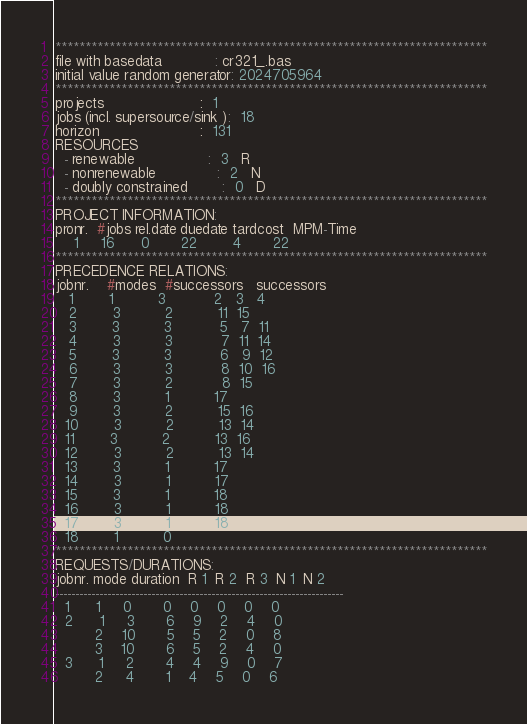<code> <loc_0><loc_0><loc_500><loc_500><_ObjectiveC_>************************************************************************
file with basedata            : cr321_.bas
initial value random generator: 2024705964
************************************************************************
projects                      :  1
jobs (incl. supersource/sink ):  18
horizon                       :  131
RESOURCES
  - renewable                 :  3   R
  - nonrenewable              :  2   N
  - doubly constrained        :  0   D
************************************************************************
PROJECT INFORMATION:
pronr.  #jobs rel.date duedate tardcost  MPM-Time
    1     16      0       22        4       22
************************************************************************
PRECEDENCE RELATIONS:
jobnr.    #modes  #successors   successors
   1        1          3           2   3   4
   2        3          2          11  15
   3        3          3           5   7  11
   4        3          3           7  11  14
   5        3          3           6   9  12
   6        3          3           8  10  16
   7        3          2           8  15
   8        3          1          17
   9        3          2          15  16
  10        3          2          13  14
  11        3          2          13  16
  12        3          2          13  14
  13        3          1          17
  14        3          1          17
  15        3          1          18
  16        3          1          18
  17        3          1          18
  18        1          0        
************************************************************************
REQUESTS/DURATIONS:
jobnr. mode duration  R 1  R 2  R 3  N 1  N 2
------------------------------------------------------------------------
  1      1     0       0    0    0    0    0
  2      1     3       6    9    2    4    0
         2    10       5    5    2    0    8
         3    10       6    5    2    4    0
  3      1     2       4    4    9    0    7
         2     4       1    4    5    0    6</code> 